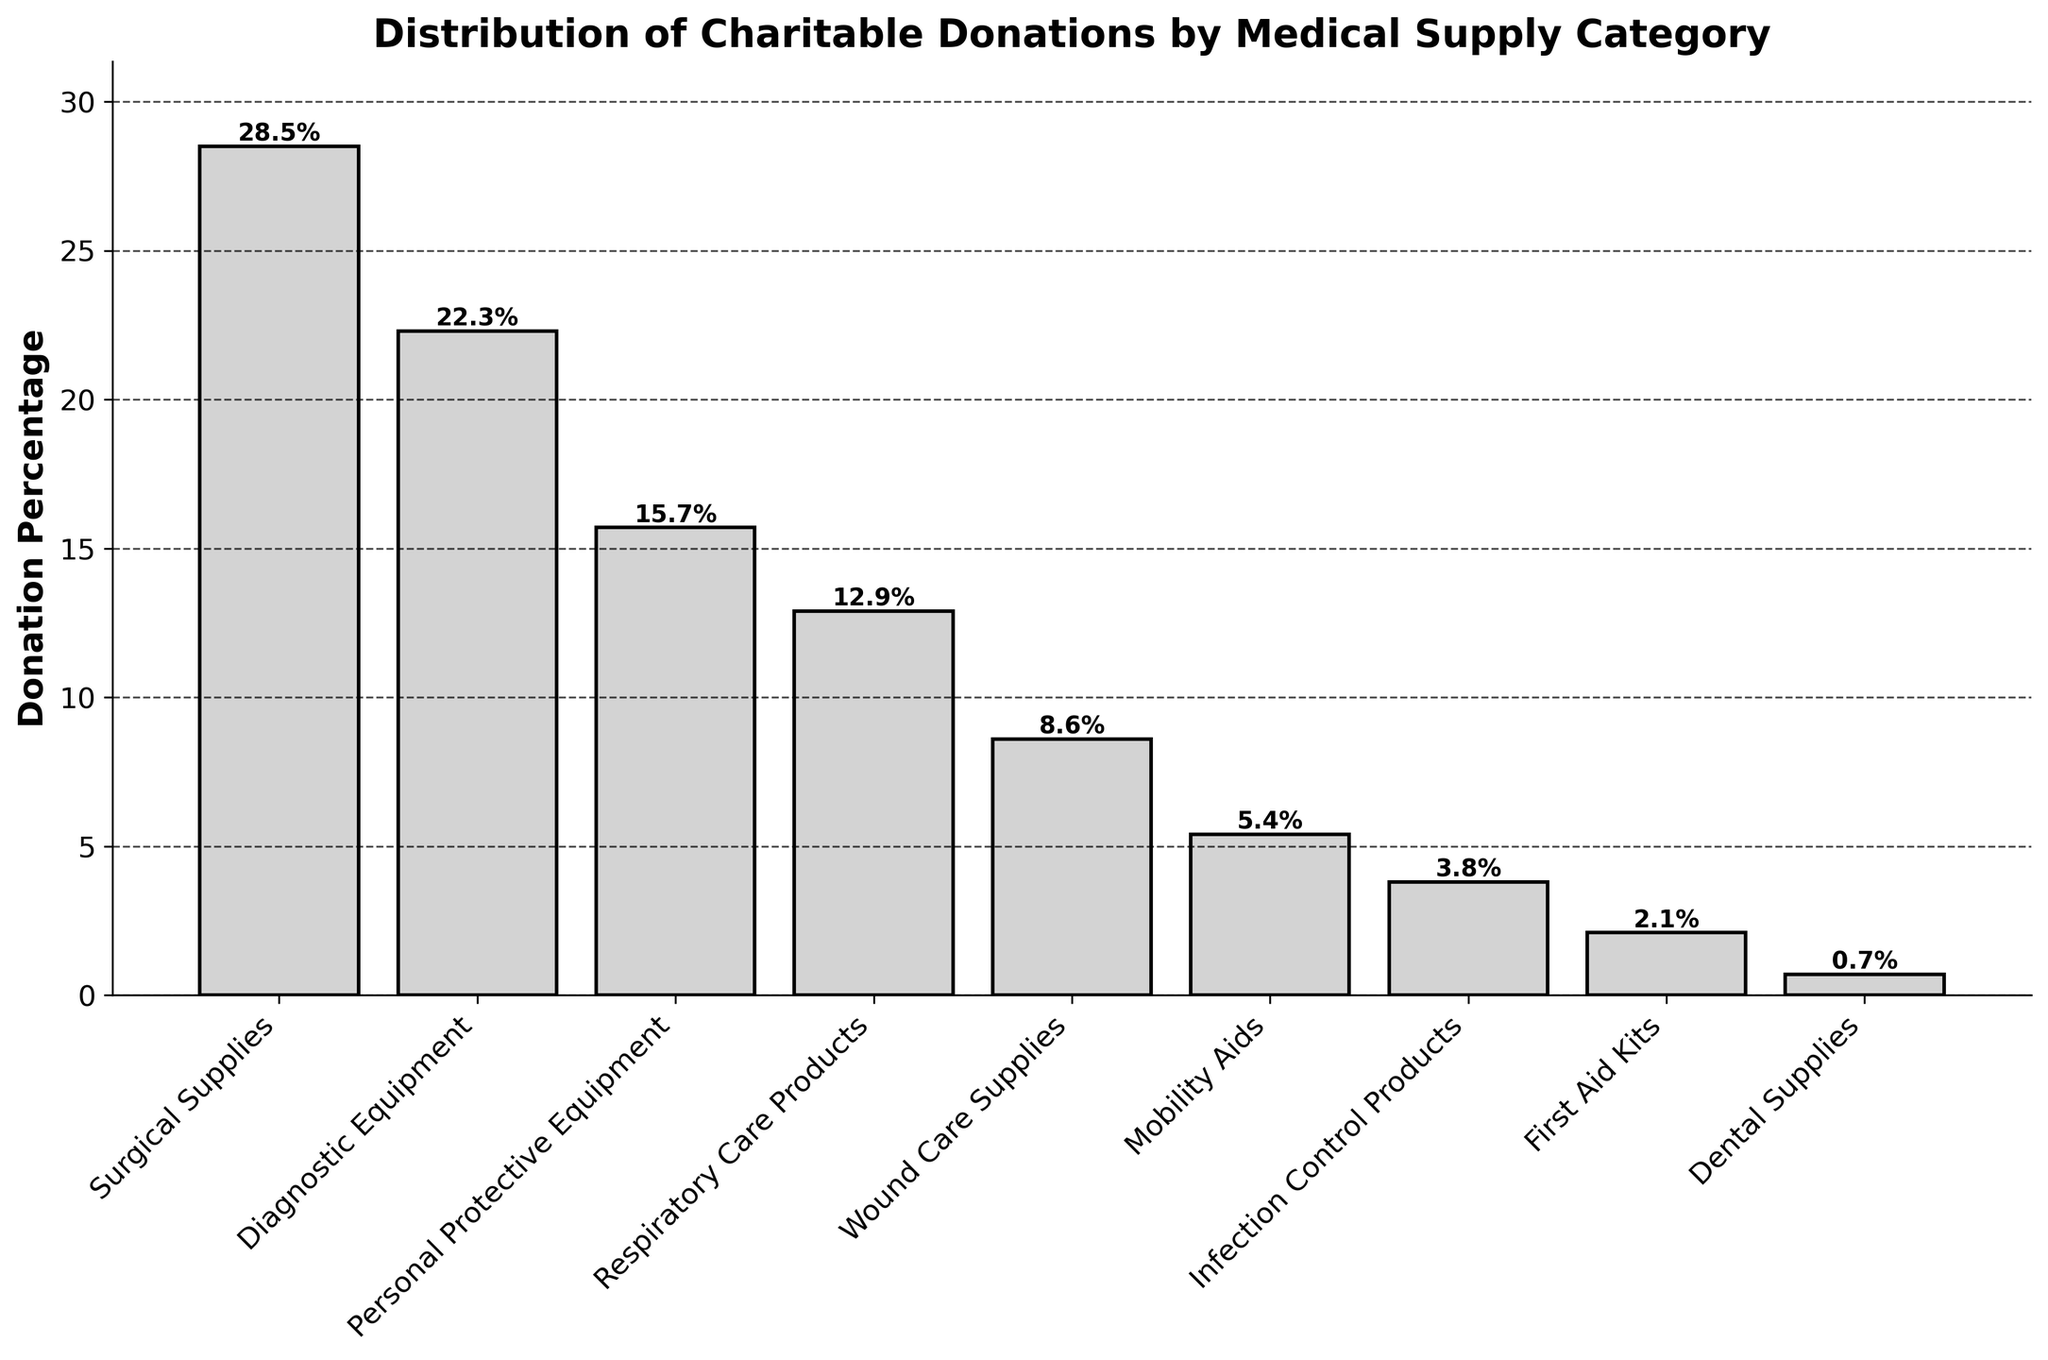What's the highest donation percentage category? Look at the bar with the greatest height, which in this case represents the "Surgical Supplies" category.
Answer: Surgical Supplies Which category has the lowest donation percentage? Identify the shortest bar in the chart, which corresponds to the "Dental Supplies" category.
Answer: Dental Supplies What is the combined donation percentage for Personal Protective Equipment and Respiratory Care Products? Add the percentages of these two categories: 15.7% (Personal Protective Equipment) + 12.9% (Respiratory Care Products).
Answer: 28.6% How much more is the donation percentage for Diagnostic Equipment compared to Infection Control Products? Subtract the percentage of Infection Control Products from Diagnostic Equipment: 22.3% - 3.8%.
Answer: 18.5% Which category has a slightly higher donation percentage than Wound Care Supplies? The category following Wound Care Supplies in percentage is "Respiratory Care Products" with 12.9%.
Answer: Respiratory Care Products List the categories that have a donation percentage below 10%. Identify bars with heights (percentages) less than 10%. These categories are Wound Care Supplies, Mobility Aids, Infection Control Products, First Aid Kits, and Dental Supplies.
Answer: Wound Care Supplies, Mobility Aids, Infection Control Products, First Aid Kits, Dental Supplies What is the difference in donation percentage between the category with the highest percentage and the category with the lowest percentage? Subtract the lowest percentage (Dental Supplies, 0.7%) from the highest percentage (Surgical Supplies, 28.5%).
Answer: 27.8% Which category falls exactly at the median donation percentage? The median can be found by ordering the categories by their donation percentages and picking the middle one (or averaging the two middle ones if the number of categories is even). The ordered list is: Dental Supplies, First Aid Kits, Infection Control Products, Mobility Aids, Wound Care Supplies, Respiratory Care Products, Personal Protective Equipment, Diagnostic Equipment, Surgical Supplies. The middle category is "Wound Care Supplies".
Answer: Wound Care Supplies 